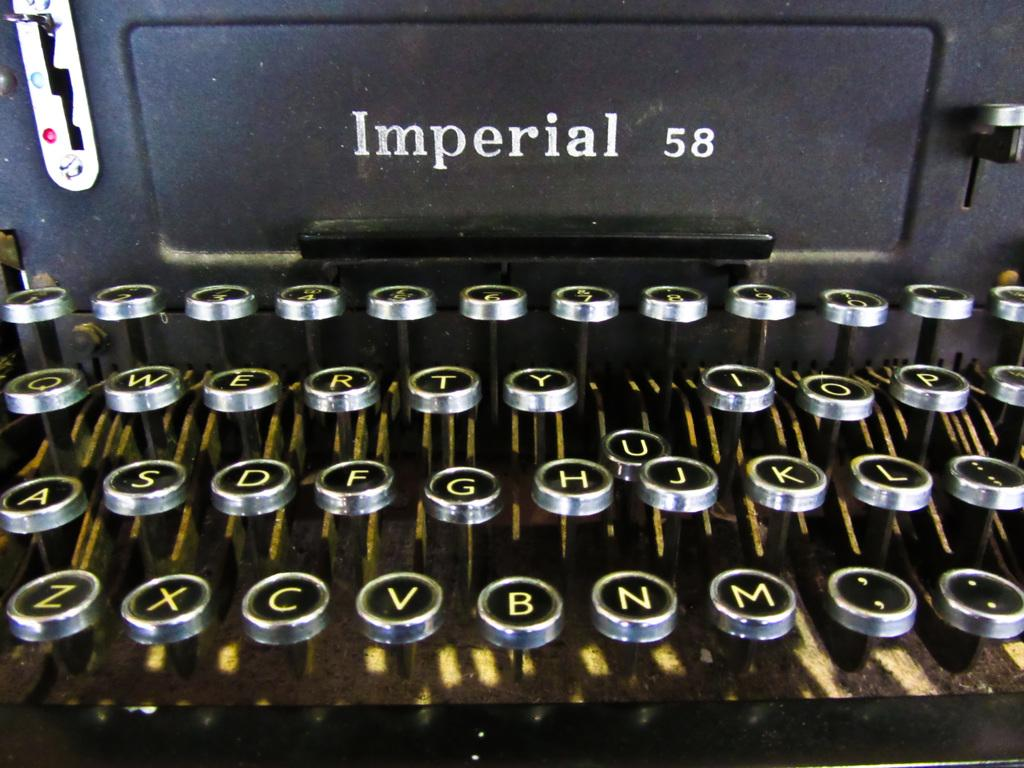<image>
Render a clear and concise summary of the photo. An old Imperial 58 typewrite has the U key depressed. 